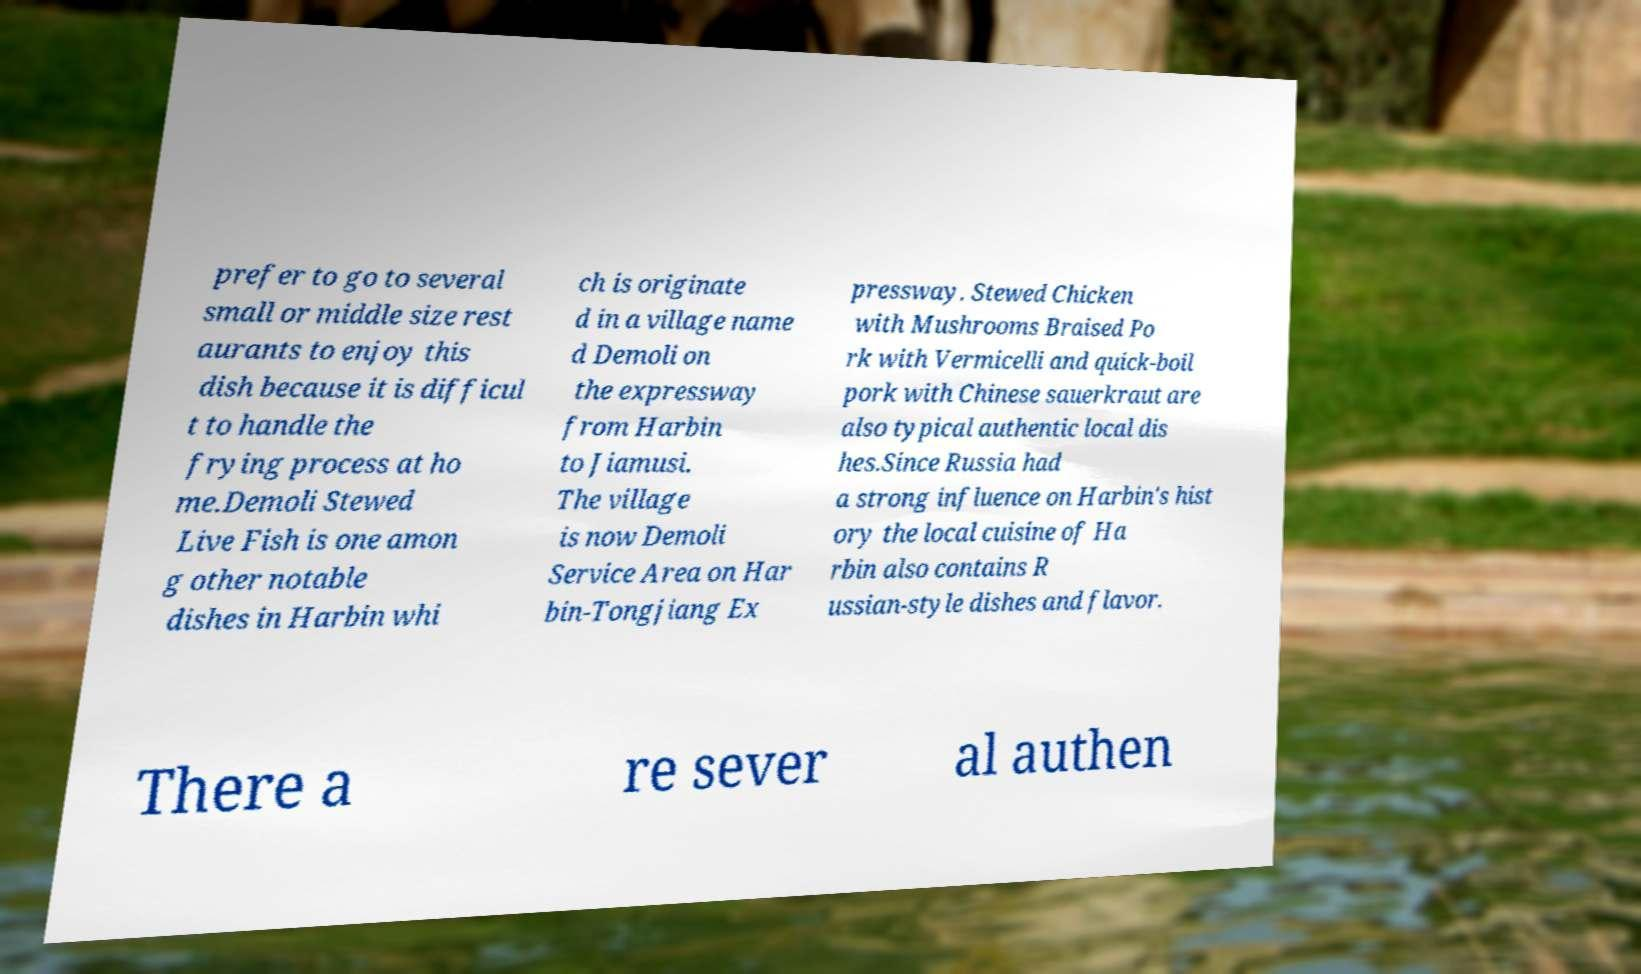What messages or text are displayed in this image? I need them in a readable, typed format. prefer to go to several small or middle size rest aurants to enjoy this dish because it is difficul t to handle the frying process at ho me.Demoli Stewed Live Fish is one amon g other notable dishes in Harbin whi ch is originate d in a village name d Demoli on the expressway from Harbin to Jiamusi. The village is now Demoli Service Area on Har bin-Tongjiang Ex pressway. Stewed Chicken with Mushrooms Braised Po rk with Vermicelli and quick-boil pork with Chinese sauerkraut are also typical authentic local dis hes.Since Russia had a strong influence on Harbin's hist ory the local cuisine of Ha rbin also contains R ussian-style dishes and flavor. There a re sever al authen 